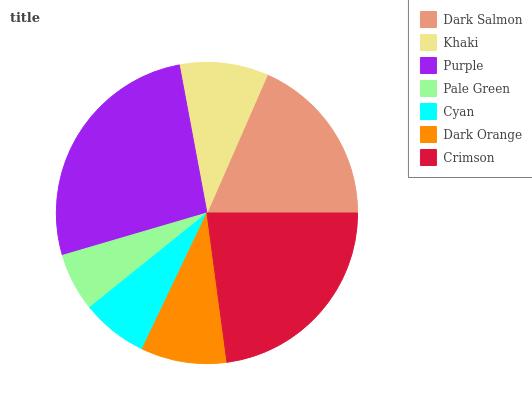Is Pale Green the minimum?
Answer yes or no. Yes. Is Purple the maximum?
Answer yes or no. Yes. Is Khaki the minimum?
Answer yes or no. No. Is Khaki the maximum?
Answer yes or no. No. Is Dark Salmon greater than Khaki?
Answer yes or no. Yes. Is Khaki less than Dark Salmon?
Answer yes or no. Yes. Is Khaki greater than Dark Salmon?
Answer yes or no. No. Is Dark Salmon less than Khaki?
Answer yes or no. No. Is Khaki the high median?
Answer yes or no. Yes. Is Khaki the low median?
Answer yes or no. Yes. Is Purple the high median?
Answer yes or no. No. Is Dark Salmon the low median?
Answer yes or no. No. 